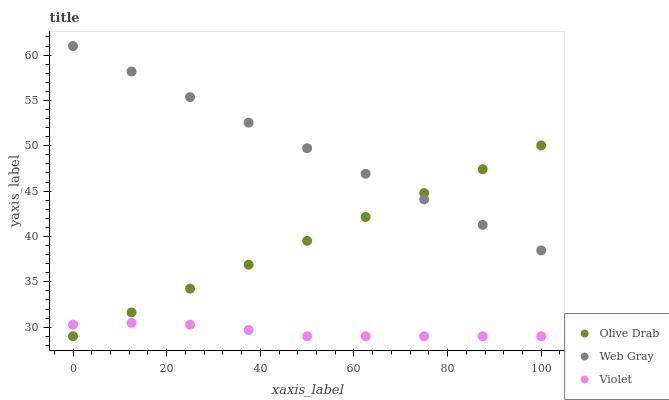Does Violet have the minimum area under the curve?
Answer yes or no. Yes. Does Web Gray have the maximum area under the curve?
Answer yes or no. Yes. Does Olive Drab have the minimum area under the curve?
Answer yes or no. No. Does Olive Drab have the maximum area under the curve?
Answer yes or no. No. Is Olive Drab the smoothest?
Answer yes or no. Yes. Is Violet the roughest?
Answer yes or no. Yes. Is Violet the smoothest?
Answer yes or no. No. Is Olive Drab the roughest?
Answer yes or no. No. Does Olive Drab have the lowest value?
Answer yes or no. Yes. Does Web Gray have the highest value?
Answer yes or no. Yes. Does Olive Drab have the highest value?
Answer yes or no. No. Is Violet less than Web Gray?
Answer yes or no. Yes. Is Web Gray greater than Violet?
Answer yes or no. Yes. Does Web Gray intersect Olive Drab?
Answer yes or no. Yes. Is Web Gray less than Olive Drab?
Answer yes or no. No. Is Web Gray greater than Olive Drab?
Answer yes or no. No. Does Violet intersect Web Gray?
Answer yes or no. No. 